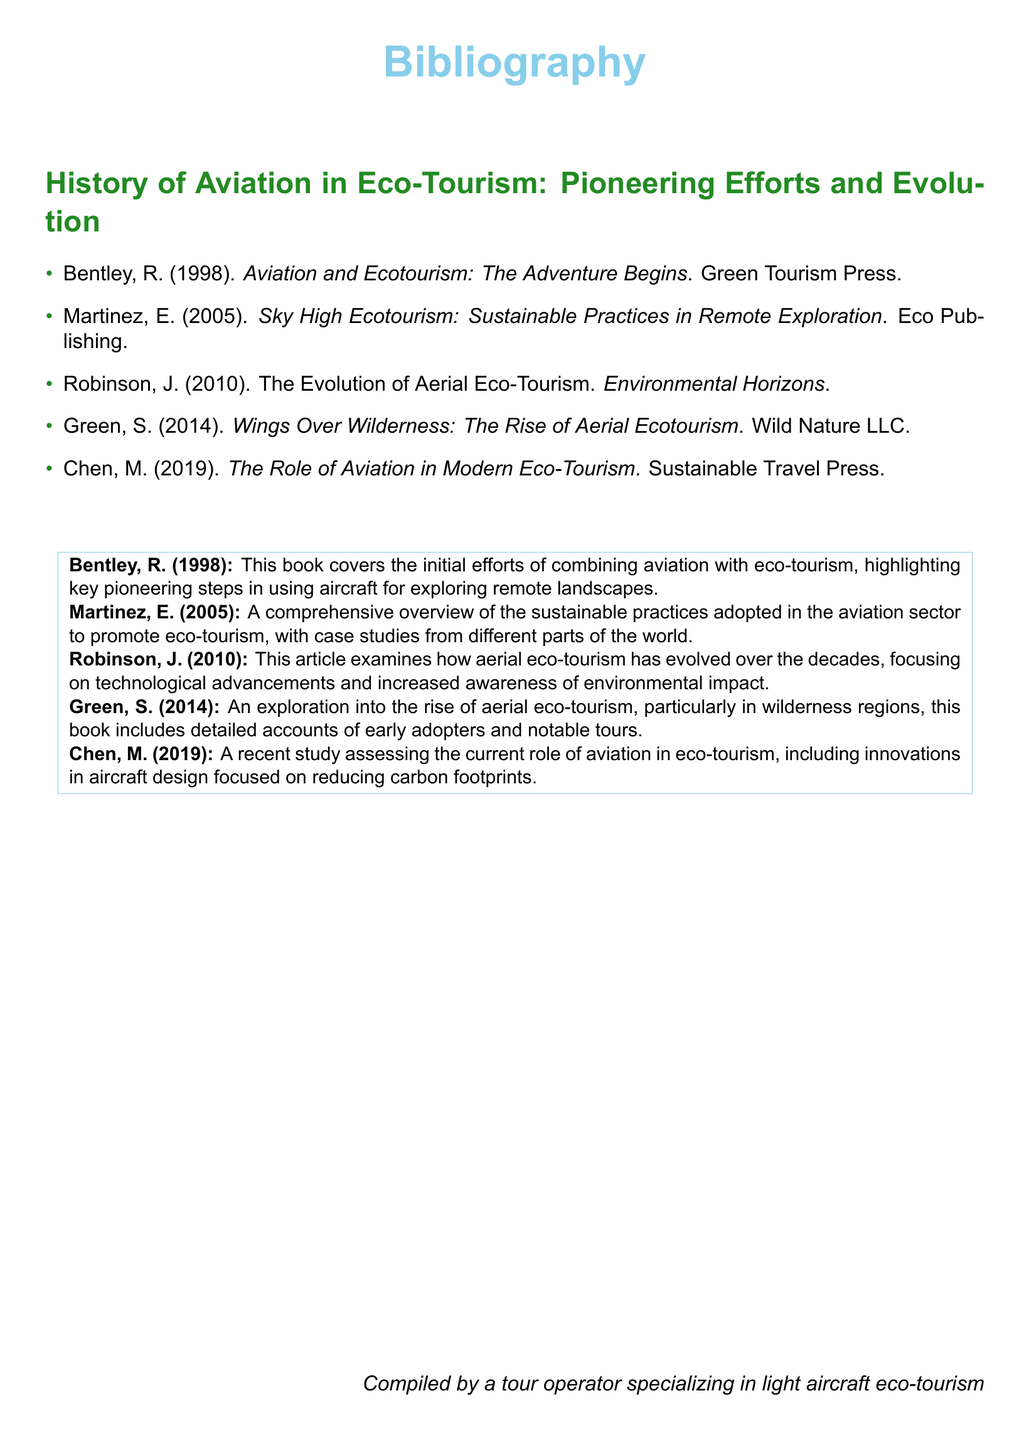What is the title of the first entry? The title of the first entry is found in the bibliography list under Bentley, R. (1998).
Answer: Aviation and Ecotourism: The Adventure Begins Who authored the book published in 2005? The author of the book published in 2005 can be found next to Martinez, E. in the bibliography.
Answer: Martinez, E In what year was the article by Robinson published? The year of publication for the article by Robinson can be seen following his name in the bibliography list.
Answer: 2010 What is the main focus of the book by Chen, M. (2019)? The main focus is described in the summary of Chen's work found below the bibliography list.
Answer: The current role of aviation in eco-tourism Which publisher released the book titled "Wings Over Wilderness"? The publisher of this book is indicated next to Green, S. in the bibliography.
Answer: Wild Nature LLC What common theme is present in the works listed in the bibliography? The common theme among the works is eco-tourism, as suggested by the titles and summaries.
Answer: Eco-tourism How many entries are included in the bibliography? The total number of entries can be counted from the bibliography list provided.
Answer: 5 What color is used for the section headers in the document? The color of the section headers can be observed in the formatted text of the document.
Answer: Forest green 